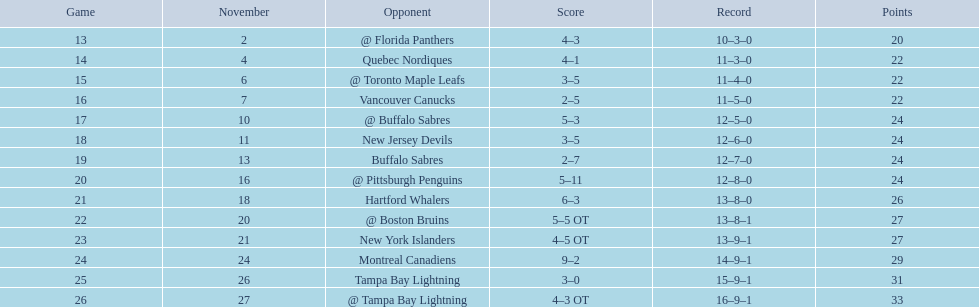In the 17th game, which team competed against the philadelphia flyers? @ Buffalo Sabres. What was the outcome of the match on november 10th against the buffalo sabres? 5–3. Which atlantic division team had a lower points total than the philadelphia flyers? Tampa Bay Lightning. 